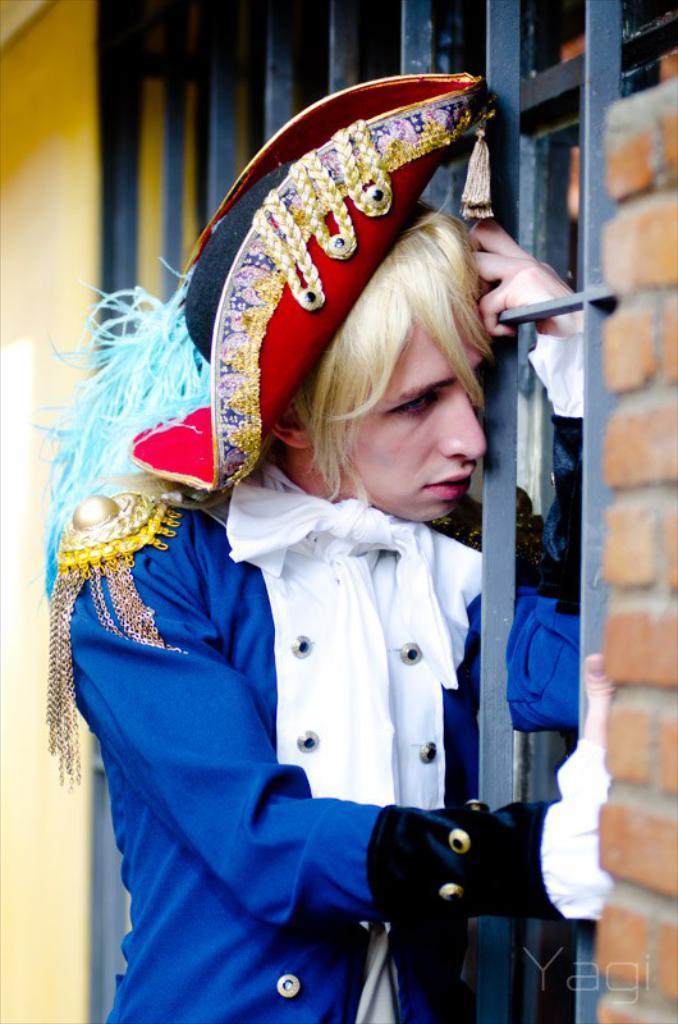How would you summarize this image in a sentence or two? In this picture we can see a person in the fancy dress. Behind the person there are iron grills and a wall. 